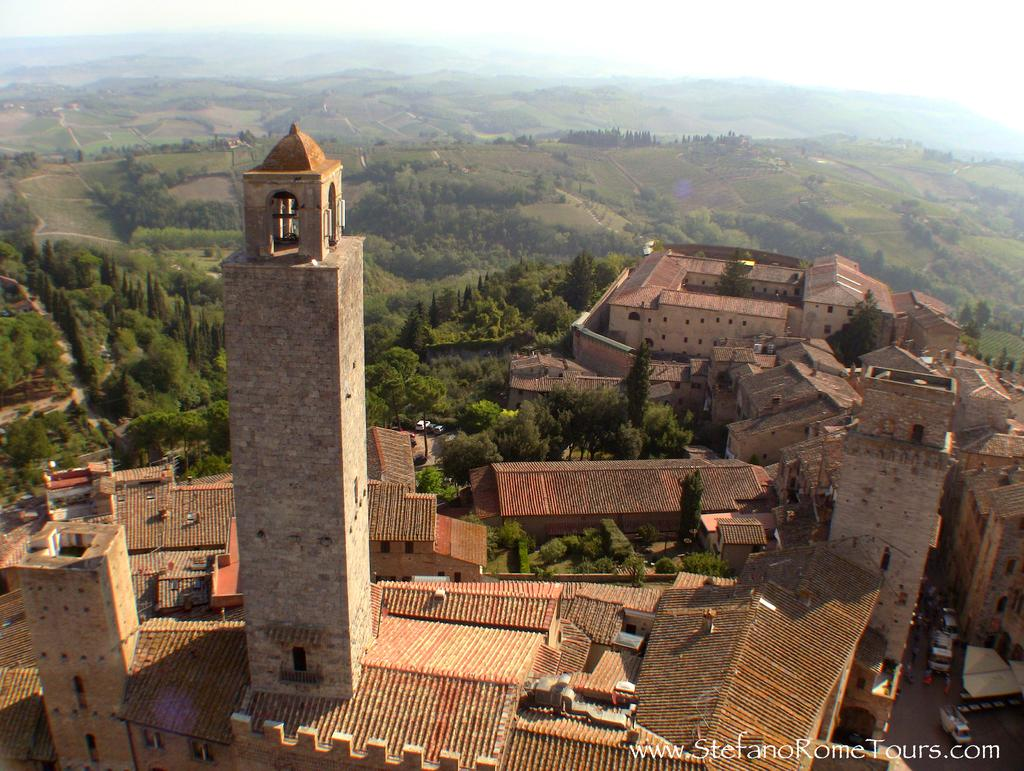What type of structures can be seen in the image? There are buildings in the image. What is happening on the road in the image? Motor vehicles are present on the road in the image. What type of vegetation is visible in the image? There are trees in the image. What natural feature can be seen in the distance in the image? Hills are visible in the image. What is visible above the buildings and trees in the image? The sky is visible in the image. What is the opinion of the quarter on the buildings in the image? There is no quarter present in the image, and therefore it cannot have an opinion on the buildings. 